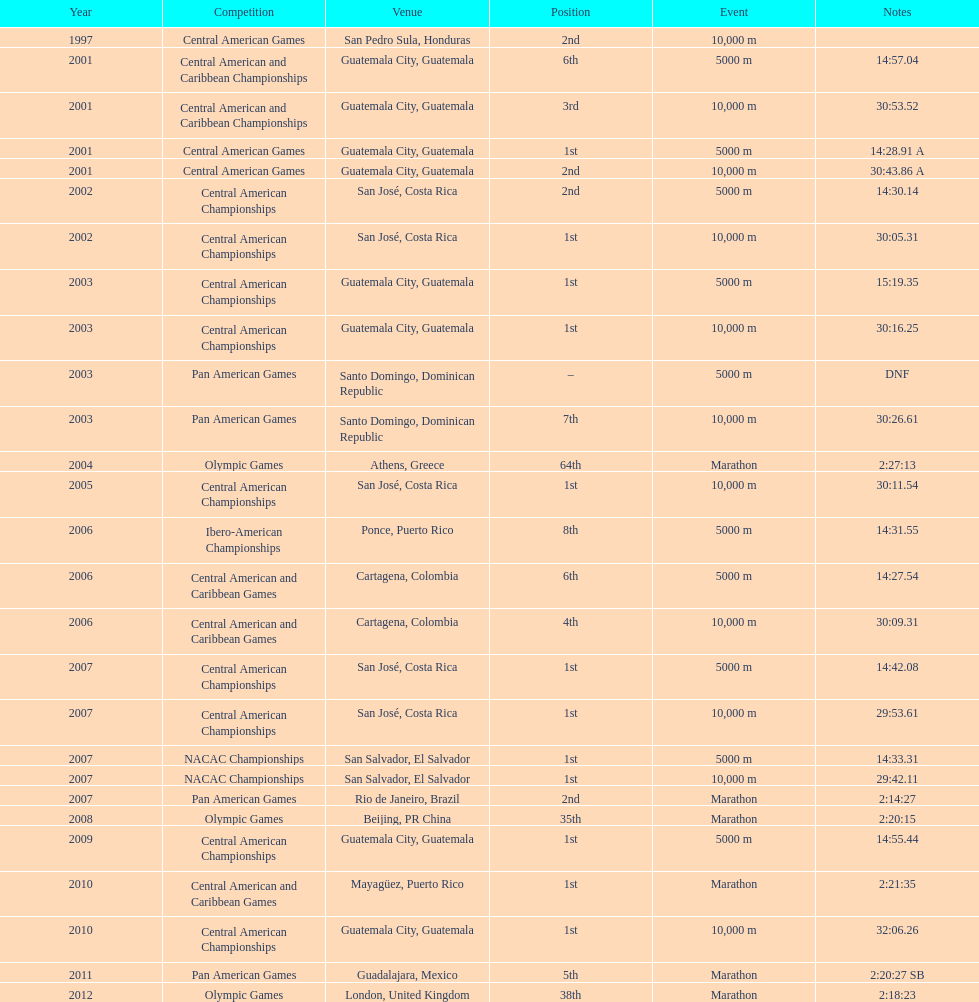What was the first competition this competitor competed in? Central American Games. 